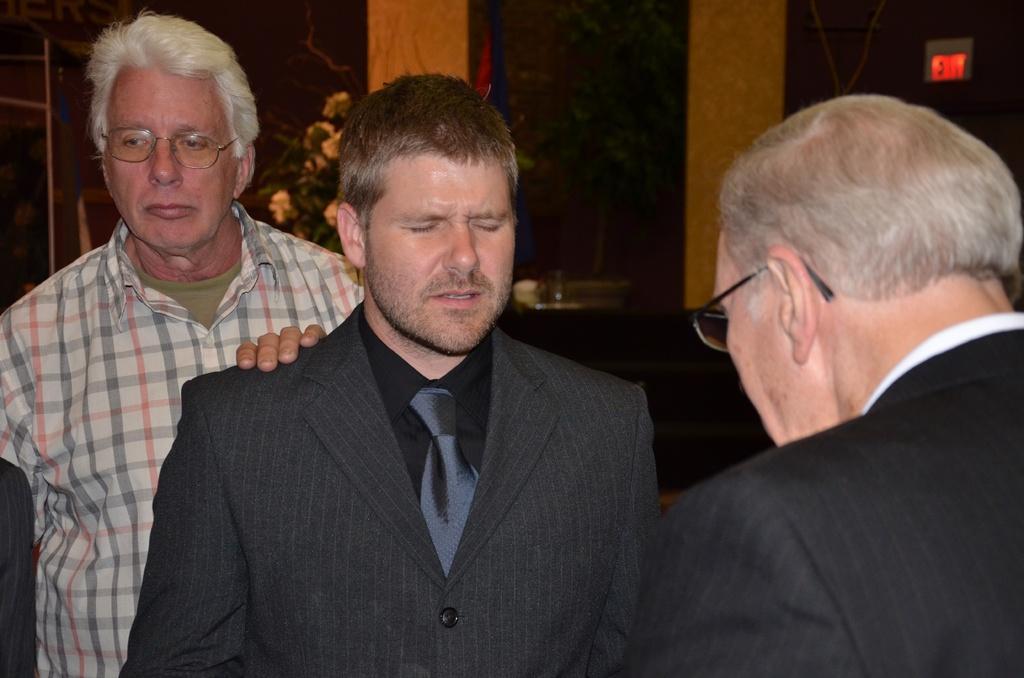How would you summarize this image in a sentence or two? In this image we can see three men standing. On the backside we can see a plant in a pot, a wall and a signboard. 